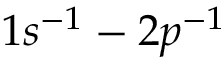<formula> <loc_0><loc_0><loc_500><loc_500>1 s ^ { - 1 } - 2 p ^ { - 1 }</formula> 